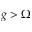<formula> <loc_0><loc_0><loc_500><loc_500>g > \Omega</formula> 